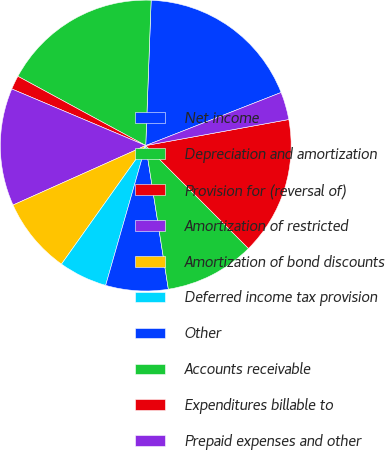Convert chart to OTSL. <chart><loc_0><loc_0><loc_500><loc_500><pie_chart><fcel>Net income<fcel>Depreciation and amortization<fcel>Provision for (reversal of)<fcel>Amortization of restricted<fcel>Amortization of bond discounts<fcel>Deferred income tax provision<fcel>Other<fcel>Accounts receivable<fcel>Expenditures billable to<fcel>Prepaid expenses and other<nl><fcel>18.46%<fcel>17.69%<fcel>1.54%<fcel>13.07%<fcel>8.46%<fcel>5.39%<fcel>6.93%<fcel>10.0%<fcel>15.38%<fcel>3.08%<nl></chart> 